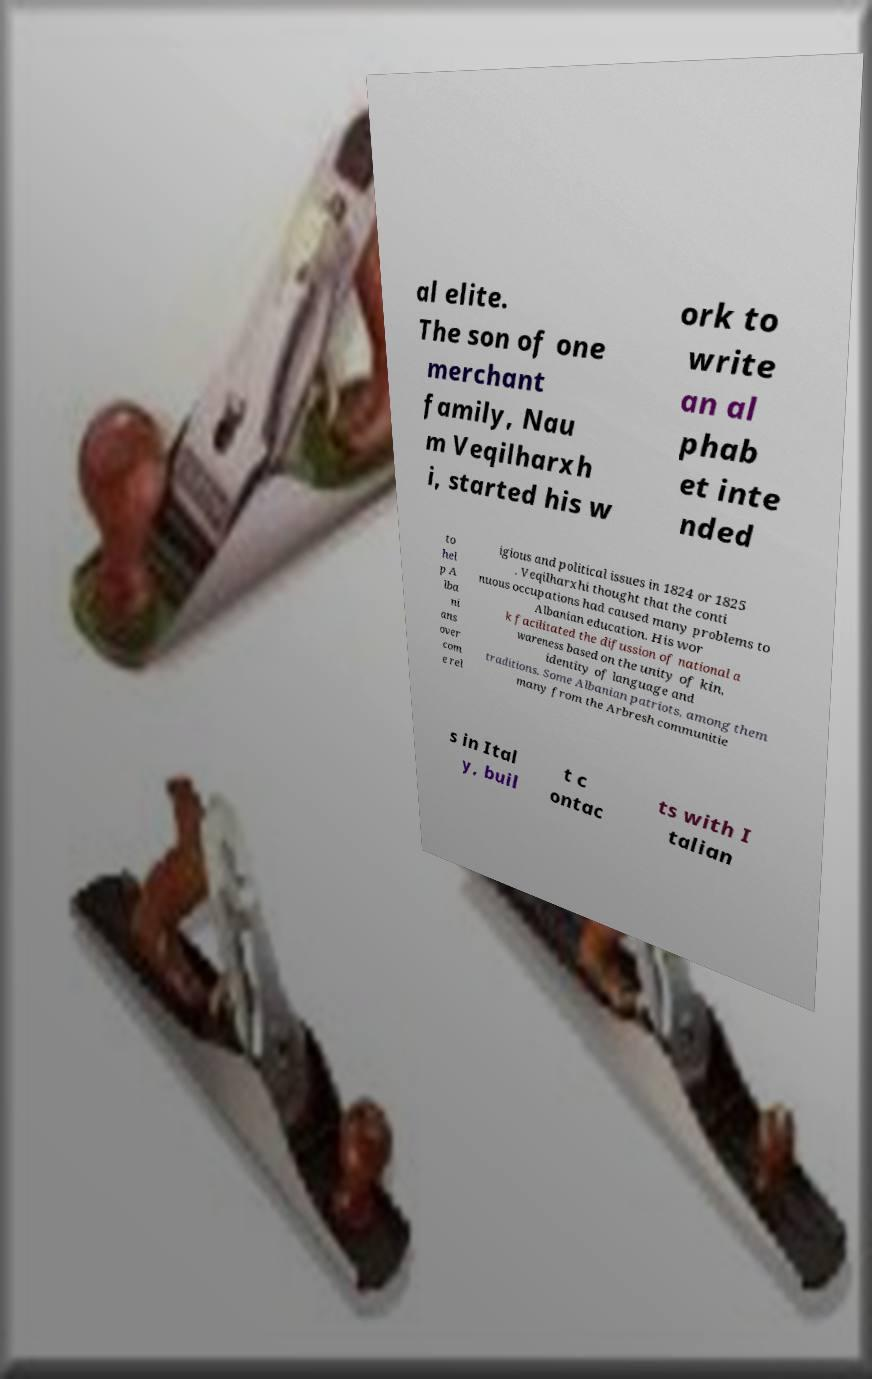Please read and relay the text visible in this image. What does it say? al elite. The son of one merchant family, Nau m Veqilharxh i, started his w ork to write an al phab et inte nded to hel p A lba ni ans over com e rel igious and political issues in 1824 or 1825 . Veqilharxhi thought that the conti nuous occupations had caused many problems to Albanian education. His wor k facilitated the difussion of national a wareness based on the unity of kin, identity of language and traditions. Some Albanian patriots, among them many from the Arbresh communitie s in Ital y, buil t c ontac ts with I talian 